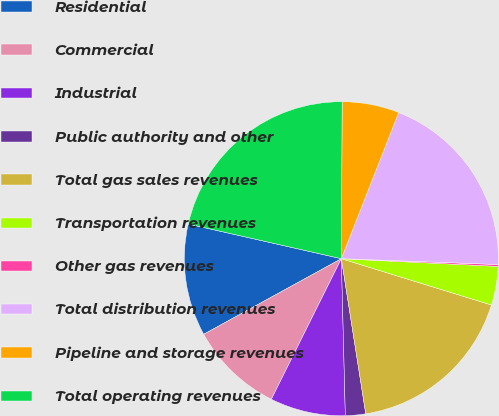Convert chart. <chart><loc_0><loc_0><loc_500><loc_500><pie_chart><fcel>Residential<fcel>Commercial<fcel>Industrial<fcel>Public authority and other<fcel>Total gas sales revenues<fcel>Transportation revenues<fcel>Other gas revenues<fcel>Total distribution revenues<fcel>Pipeline and storage revenues<fcel>Total operating revenues<nl><fcel>11.54%<fcel>9.65%<fcel>7.76%<fcel>2.08%<fcel>17.75%<fcel>3.98%<fcel>0.19%<fcel>19.64%<fcel>5.87%<fcel>21.53%<nl></chart> 